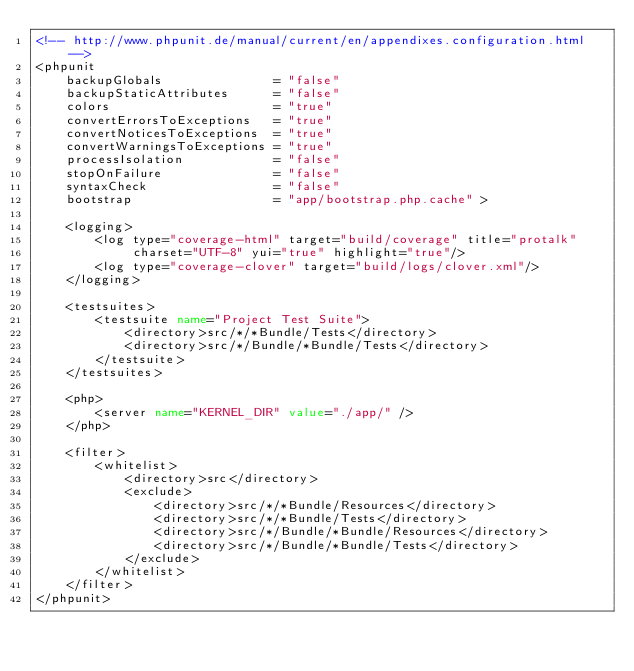<code> <loc_0><loc_0><loc_500><loc_500><_XML_><!-- http://www.phpunit.de/manual/current/en/appendixes.configuration.html -->
<phpunit
    backupGlobals               = "false"
    backupStaticAttributes      = "false"
    colors                      = "true"
    convertErrorsToExceptions   = "true"
    convertNoticesToExceptions  = "true"
    convertWarningsToExceptions = "true"
    processIsolation            = "false"
    stopOnFailure               = "false"
    syntaxCheck                 = "false"
    bootstrap                   = "app/bootstrap.php.cache" >

    <logging>
        <log type="coverage-html" target="build/coverage" title="protalk"
             charset="UTF-8" yui="true" highlight="true"/>
        <log type="coverage-clover" target="build/logs/clover.xml"/>
    </logging>

    <testsuites>
        <testsuite name="Project Test Suite">
            <directory>src/*/*Bundle/Tests</directory>
            <directory>src/*/Bundle/*Bundle/Tests</directory>
        </testsuite>
    </testsuites>

    <php>
        <server name="KERNEL_DIR" value="./app/" />
    </php>

    <filter>
        <whitelist>
            <directory>src</directory>
            <exclude>
                <directory>src/*/*Bundle/Resources</directory>
                <directory>src/*/*Bundle/Tests</directory>
                <directory>src/*/Bundle/*Bundle/Resources</directory>
                <directory>src/*/Bundle/*Bundle/Tests</directory>
            </exclude>
        </whitelist>
    </filter>
</phpunit>
</code> 